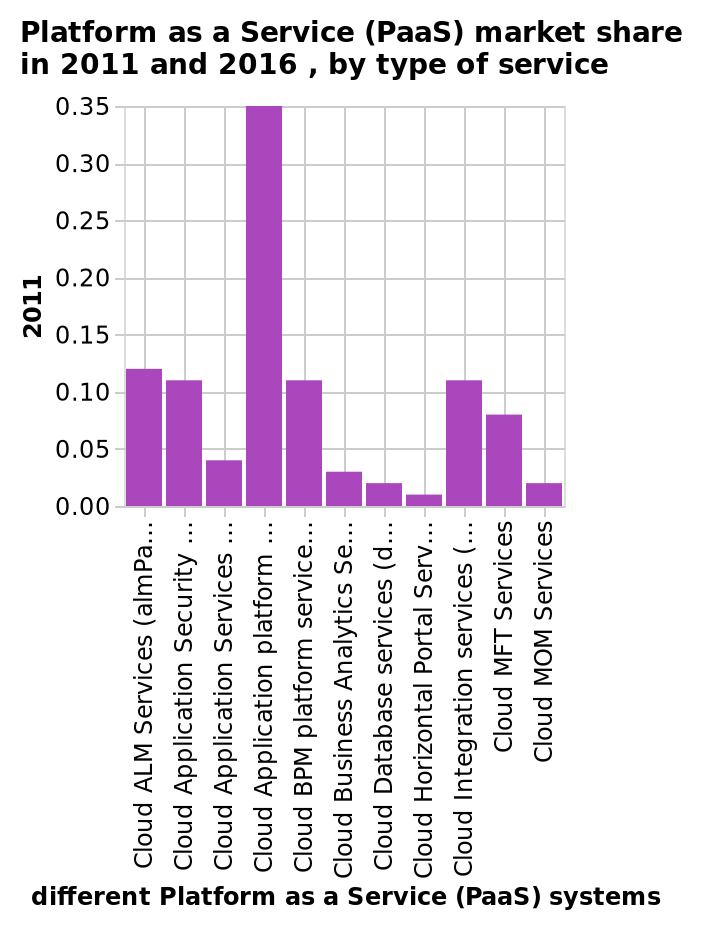<image>
What is the title of the bar diagram?  The title of the bar diagram is "Platform as a Service (PaaS) market share in 2011 and 2016, by type of service." What does the bar diagram show? The bar diagram shows the market share of different types of services in the Platform as a Service (PaaS) market for the years 2011 and 2016. please enumerates aspects of the construction of the chart Here a bar diagram is titled Platform as a Service (PaaS) market share in 2011 and 2016 , by type of service. The x-axis plots different Platform as a Service (PaaS) systems while the y-axis shows 2011. please summary the statistics and relations of the chart The cloud application platform scored the highest. What is the highest-scoring platform mentioned in the figure? The highest-scoring platform mentioned in the figure is the cloud application platform. 